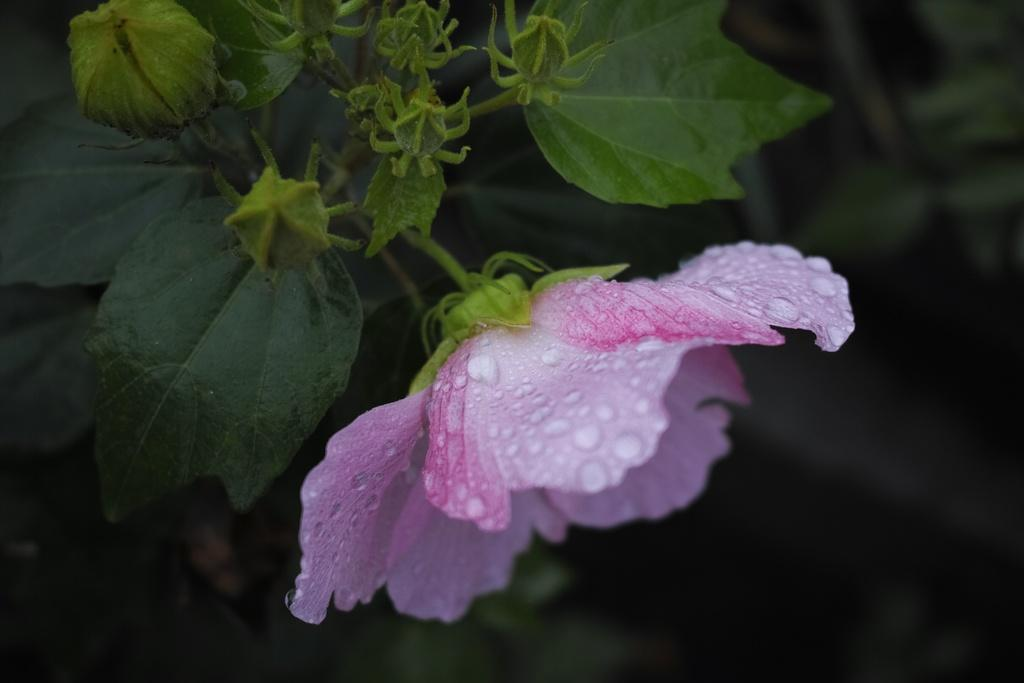What type of plant can be seen in the image? There is a flower in the image. What stage of growth are some parts of the plant in? There are buds in the image, which are in an early stage of growth. What other parts of the plant are visible in the image? There are leaves in the image. How would you describe the overall appearance of the image? The background of the image is dark. What is the purpose of the hand in the image? There is no hand present in the image. 